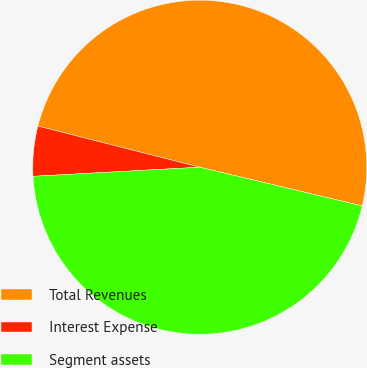Convert chart to OTSL. <chart><loc_0><loc_0><loc_500><loc_500><pie_chart><fcel>Total Revenues<fcel>Interest Expense<fcel>Segment assets<nl><fcel>49.76%<fcel>4.83%<fcel>45.41%<nl></chart> 